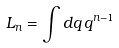<formula> <loc_0><loc_0><loc_500><loc_500>L _ { n } = \int d q \, q ^ { n - 1 }</formula> 